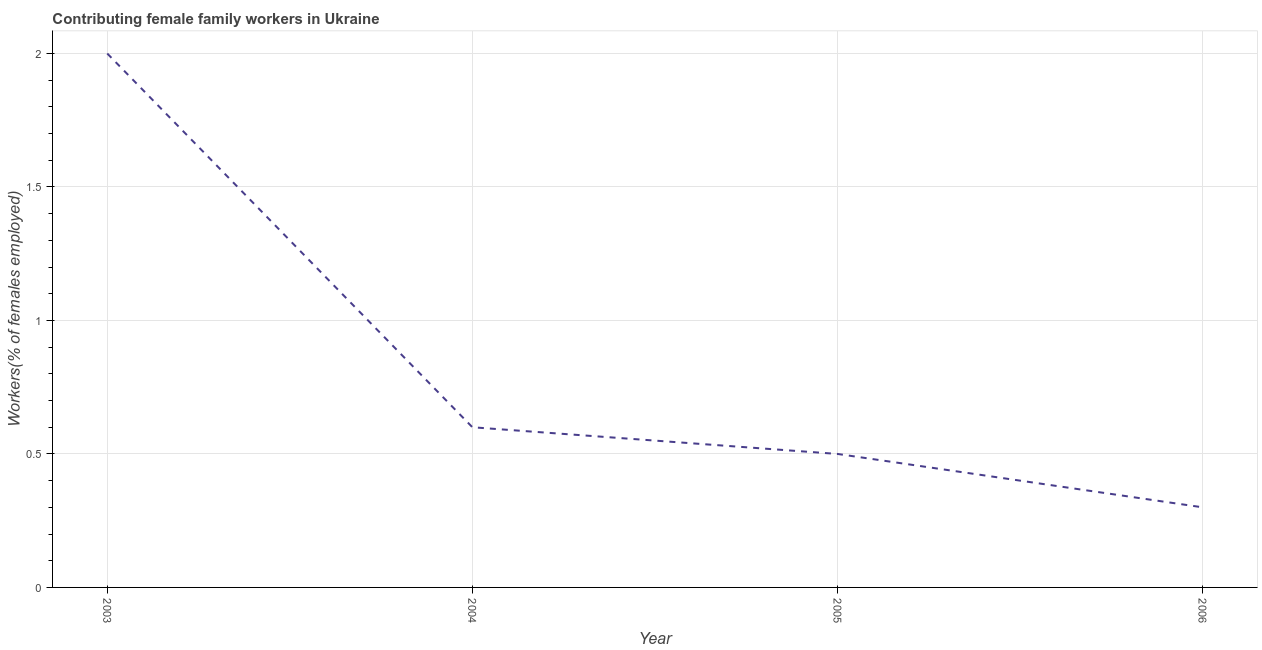What is the contributing female family workers in 2004?
Offer a very short reply. 0.6. Across all years, what is the minimum contributing female family workers?
Offer a very short reply. 0.3. In which year was the contributing female family workers maximum?
Keep it short and to the point. 2003. What is the sum of the contributing female family workers?
Keep it short and to the point. 3.4. What is the difference between the contributing female family workers in 2003 and 2006?
Ensure brevity in your answer.  1.7. What is the average contributing female family workers per year?
Your response must be concise. 0.85. What is the median contributing female family workers?
Ensure brevity in your answer.  0.55. Do a majority of the years between 2006 and 2003 (inclusive) have contributing female family workers greater than 1 %?
Make the answer very short. Yes. What is the ratio of the contributing female family workers in 2004 to that in 2005?
Your answer should be compact. 1.2. Is the difference between the contributing female family workers in 2003 and 2005 greater than the difference between any two years?
Offer a very short reply. No. What is the difference between the highest and the second highest contributing female family workers?
Ensure brevity in your answer.  1.4. What is the difference between the highest and the lowest contributing female family workers?
Your answer should be very brief. 1.7. What is the difference between two consecutive major ticks on the Y-axis?
Your answer should be very brief. 0.5. Does the graph contain any zero values?
Ensure brevity in your answer.  No. What is the title of the graph?
Provide a succinct answer. Contributing female family workers in Ukraine. What is the label or title of the X-axis?
Make the answer very short. Year. What is the label or title of the Y-axis?
Ensure brevity in your answer.  Workers(% of females employed). What is the Workers(% of females employed) of 2003?
Provide a succinct answer. 2. What is the Workers(% of females employed) of 2004?
Your answer should be compact. 0.6. What is the Workers(% of females employed) in 2005?
Provide a short and direct response. 0.5. What is the Workers(% of females employed) in 2006?
Your answer should be compact. 0.3. What is the difference between the Workers(% of females employed) in 2003 and 2004?
Your answer should be compact. 1.4. What is the difference between the Workers(% of females employed) in 2003 and 2005?
Ensure brevity in your answer.  1.5. What is the difference between the Workers(% of females employed) in 2003 and 2006?
Give a very brief answer. 1.7. What is the difference between the Workers(% of females employed) in 2004 and 2005?
Provide a short and direct response. 0.1. What is the difference between the Workers(% of females employed) in 2005 and 2006?
Ensure brevity in your answer.  0.2. What is the ratio of the Workers(% of females employed) in 2003 to that in 2004?
Make the answer very short. 3.33. What is the ratio of the Workers(% of females employed) in 2003 to that in 2005?
Make the answer very short. 4. What is the ratio of the Workers(% of females employed) in 2003 to that in 2006?
Offer a terse response. 6.67. What is the ratio of the Workers(% of females employed) in 2004 to that in 2006?
Provide a succinct answer. 2. What is the ratio of the Workers(% of females employed) in 2005 to that in 2006?
Ensure brevity in your answer.  1.67. 